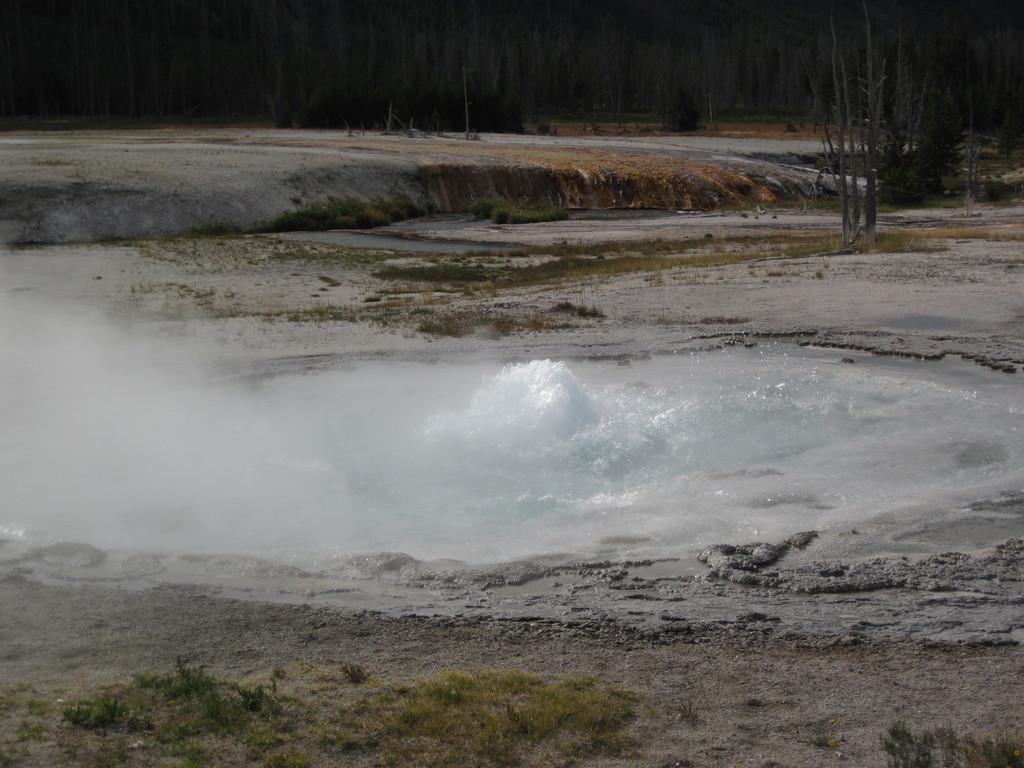What type of vegetation can be seen in the image? There is grass in the image. What else is present in the image besides grass? There is water in the image. What can be seen in the background of the image? There are dried trees in the background of the image. How would you describe the overall appearance of the image? The image has a dark appearance. How many letters are visible in the image? There are no letters present in the image. What type of list can be seen in the image? There is no list present in the image. 